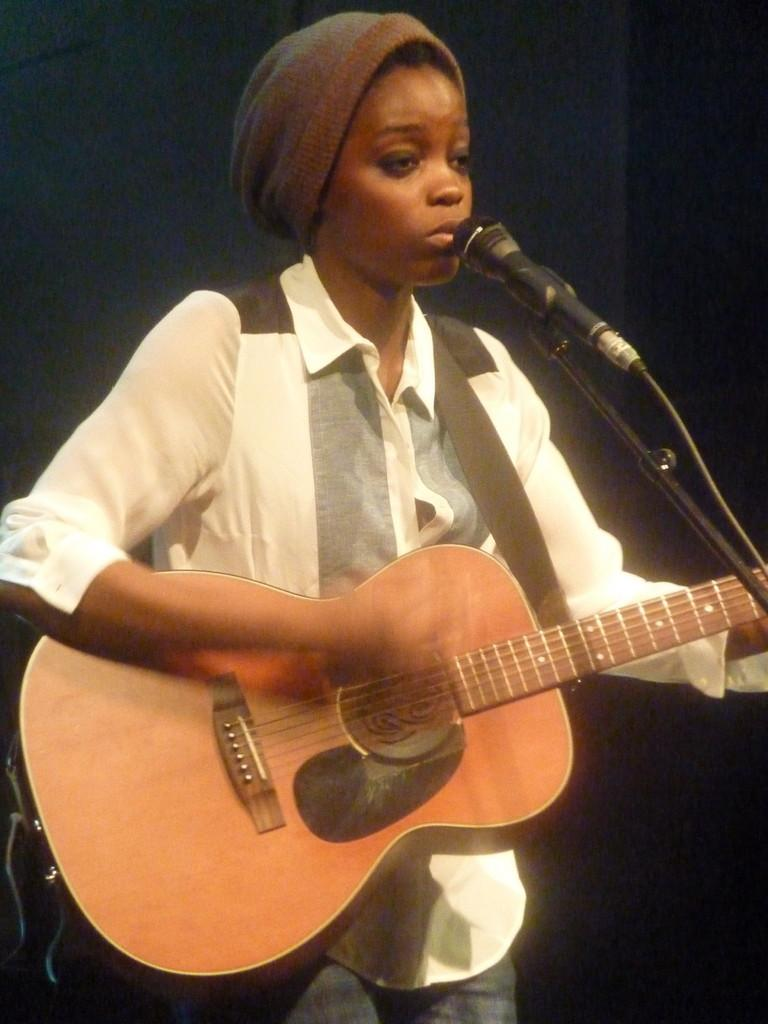Who is the main subject in the image? There is a woman in the image. What is the woman doing in the image? The woman is playing a guitar. What object is present for amplifying her voice? There is a microphone in the image. What is the woman standing near? There is a stand in the image. What might be used for connecting the guitar and microphone to a power source? There are wires in the image. What type of headwear is the woman wearing? The woman is wearing a cap on her head. What type of instrument is the woman using to crush the rocks in the image? There are no rocks or crushing instruments present in the image; the woman is playing a guitar. 